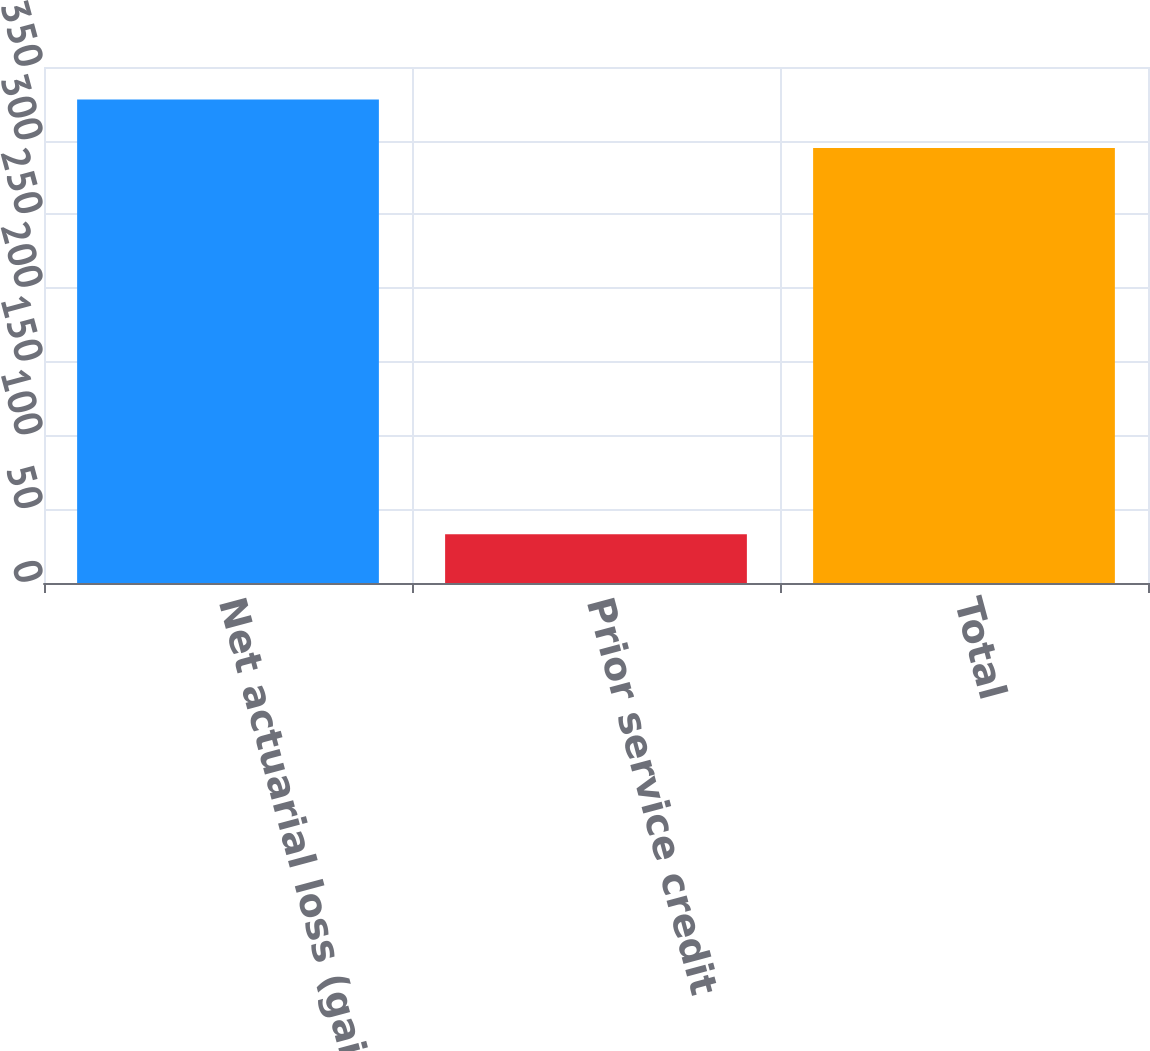<chart> <loc_0><loc_0><loc_500><loc_500><bar_chart><fcel>Net actuarial loss (gain)<fcel>Prior service credit<fcel>Total<nl><fcel>328<fcel>33<fcel>295<nl></chart> 